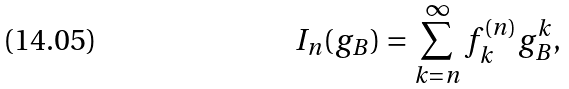Convert formula to latex. <formula><loc_0><loc_0><loc_500><loc_500>I _ { n } ( g _ { B } ) = \sum _ { k = n } ^ { \infty } f ^ { ( n ) } _ { k } g _ { B } ^ { k } ,</formula> 